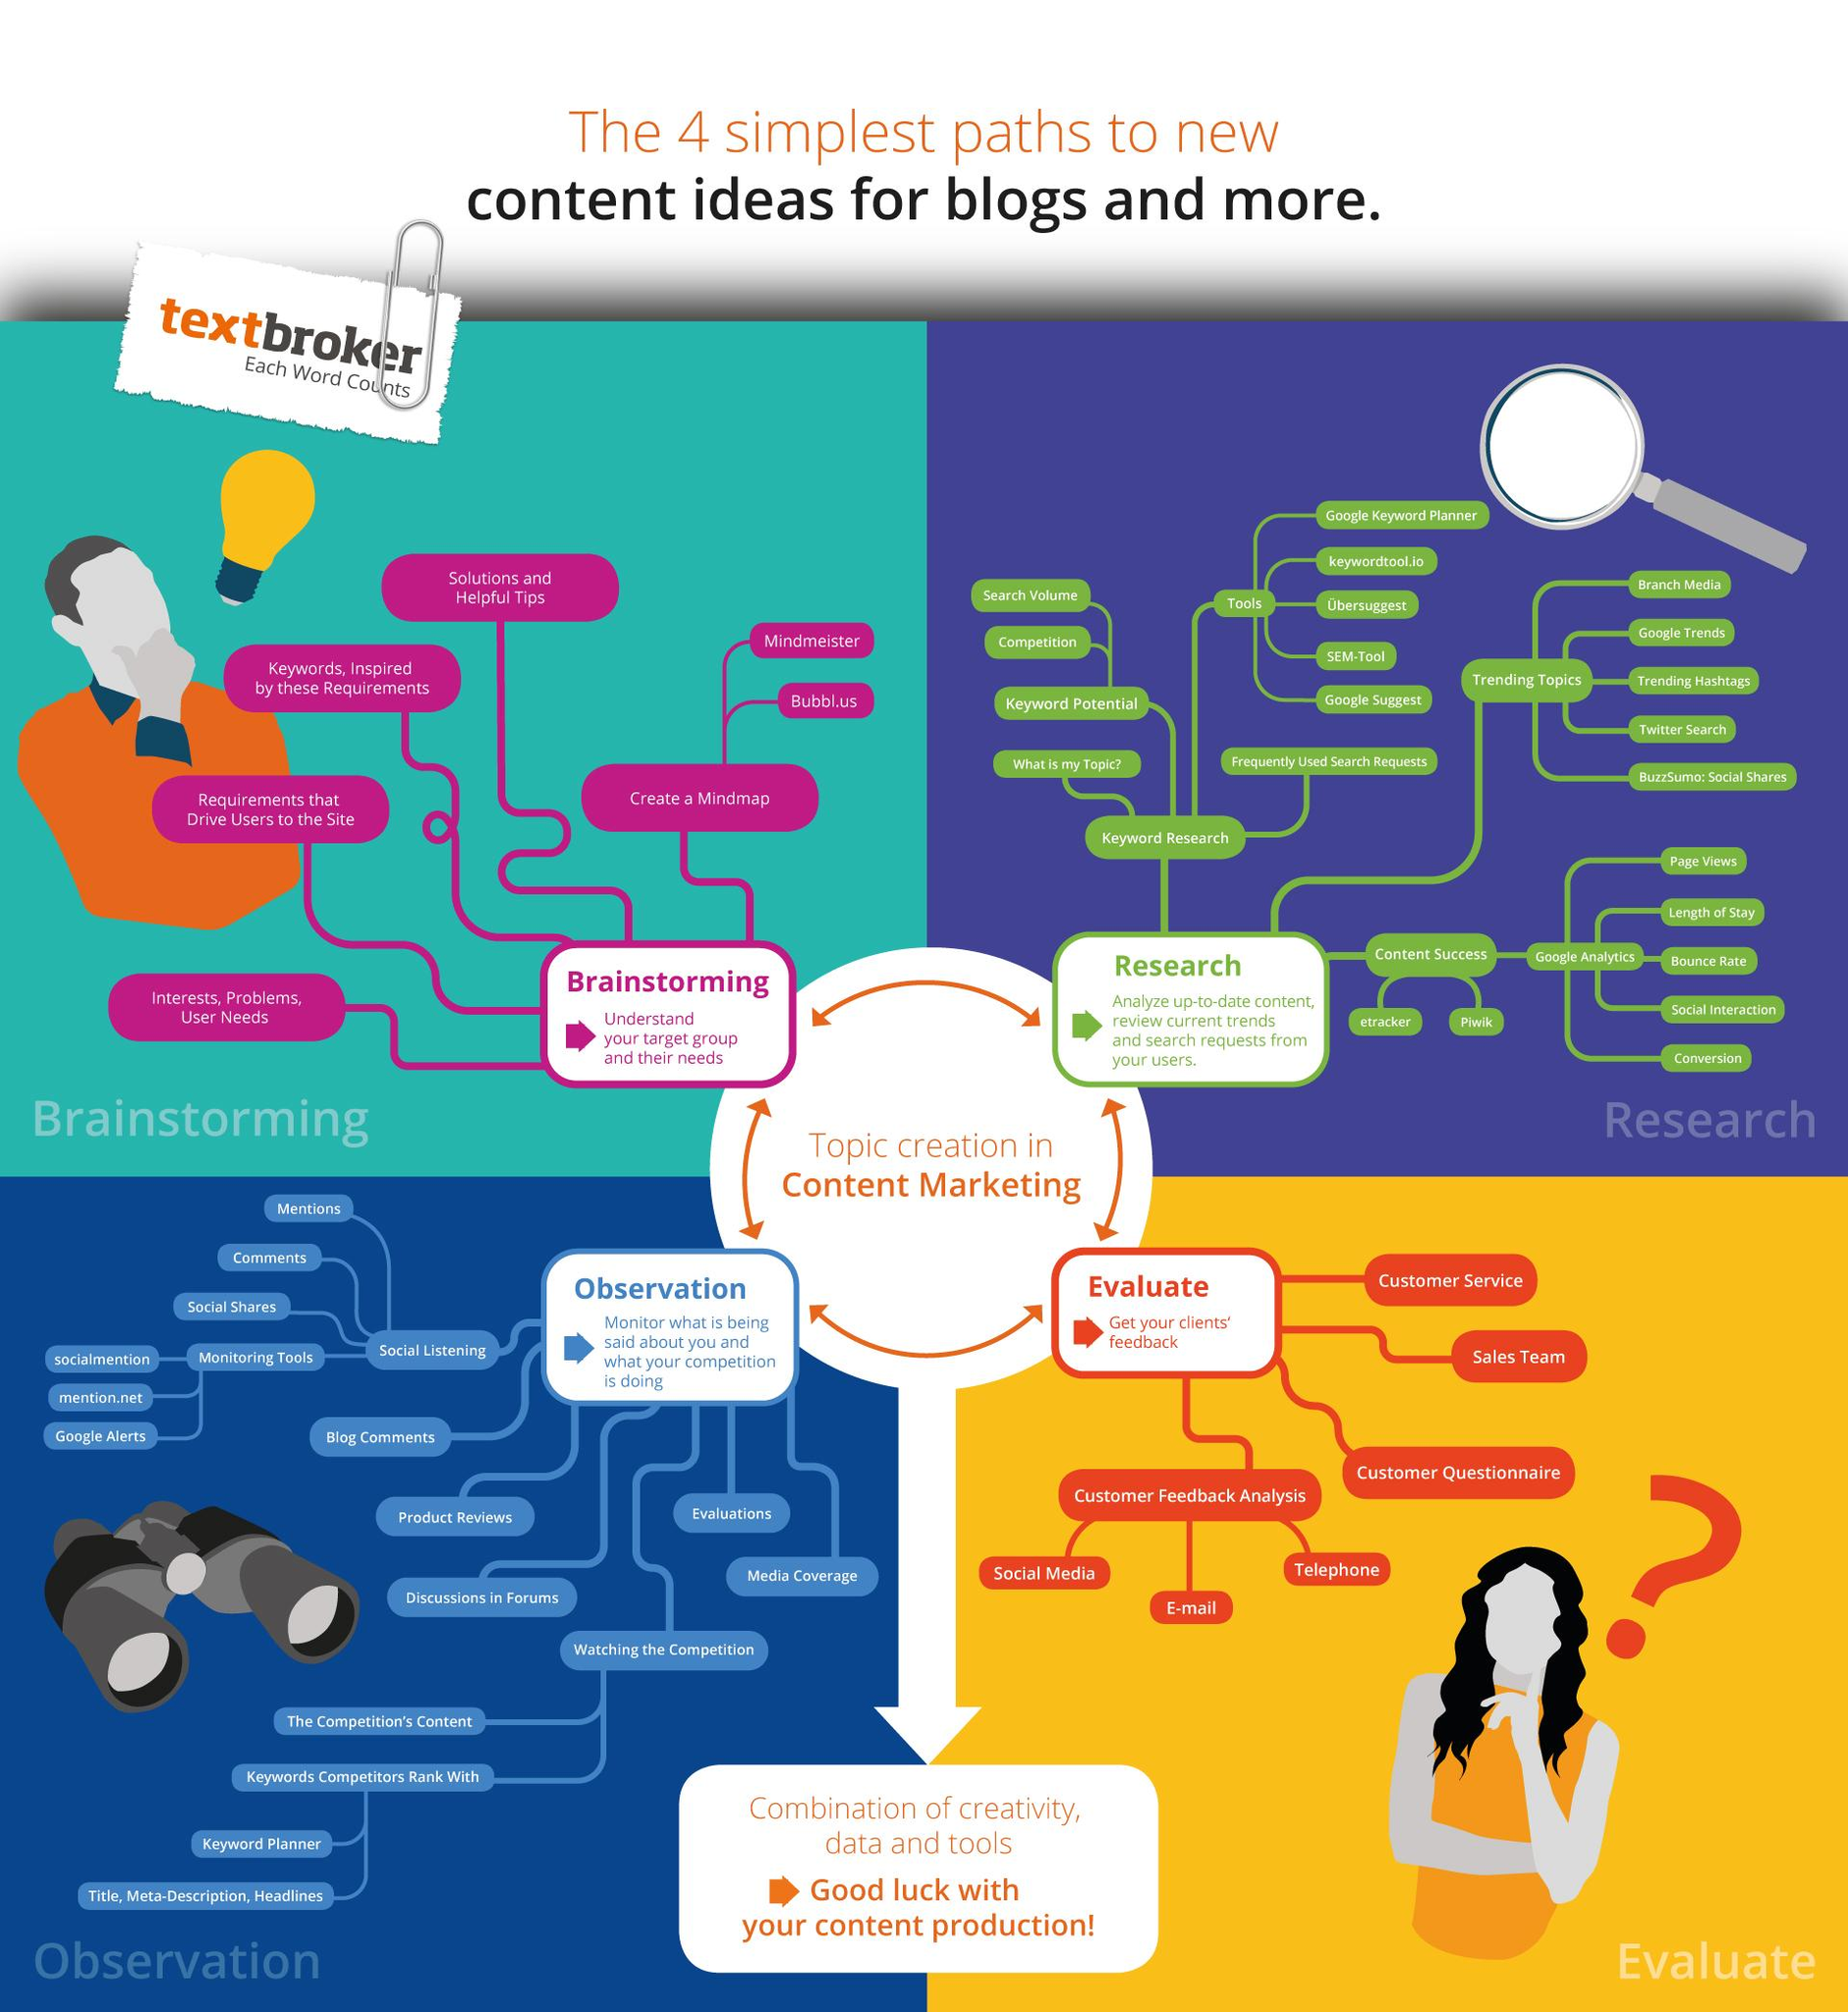Identify some key points in this picture. There are various ways to create a mind map, including Mindmeister and Bubble.us. There are various monitoring tools available, including socialmention, mention.net, and Google alerts. There are several ways to conduct social listening, including monitoring mentions, comments, and social shares. There are several methods for obtaining customer feedback, including media, social, email, and telephone. There are various ways to analyze the success of content, such as using tools like etracker and piwik. 